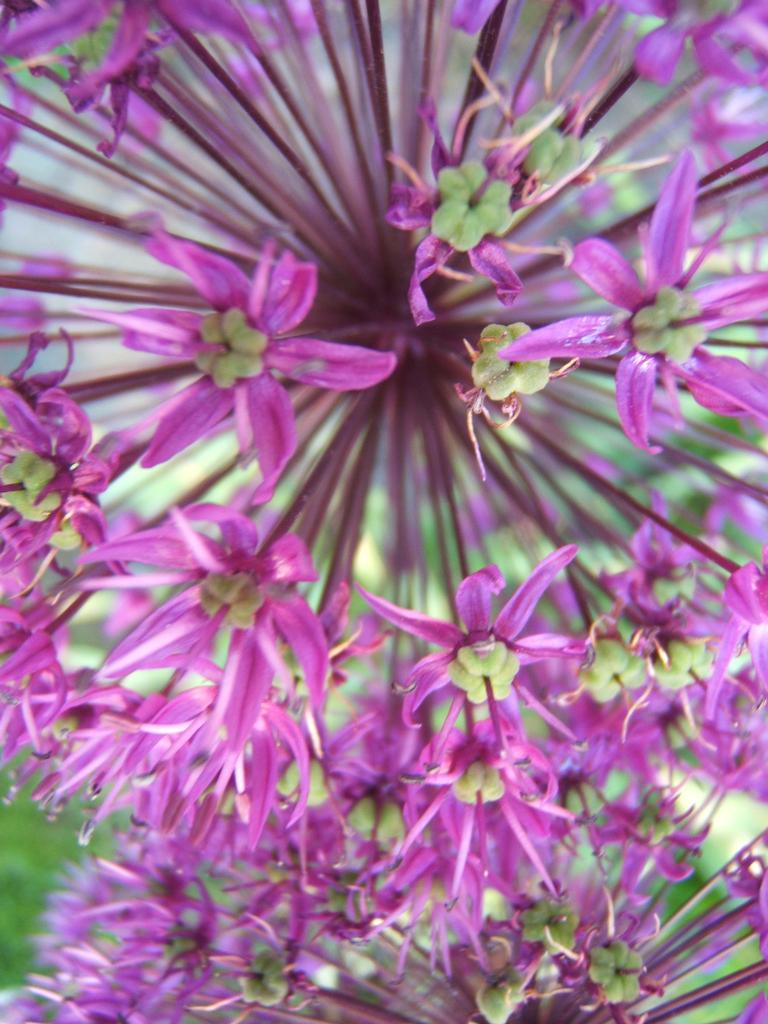What type of plants can be seen in the image? There are flowers in the image. What color are the petals of the flowers? The petals of the flowers are pink. What type of vegetation is visible at the bottom left of the image? There is grass visible in the bottom left of the image. How much milk is being delivered in the image? There is no milk or delivery mentioned in the image; it features flowers and grass. 